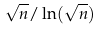Convert formula to latex. <formula><loc_0><loc_0><loc_500><loc_500>\sqrt { n } / \ln ( \sqrt { n } )</formula> 